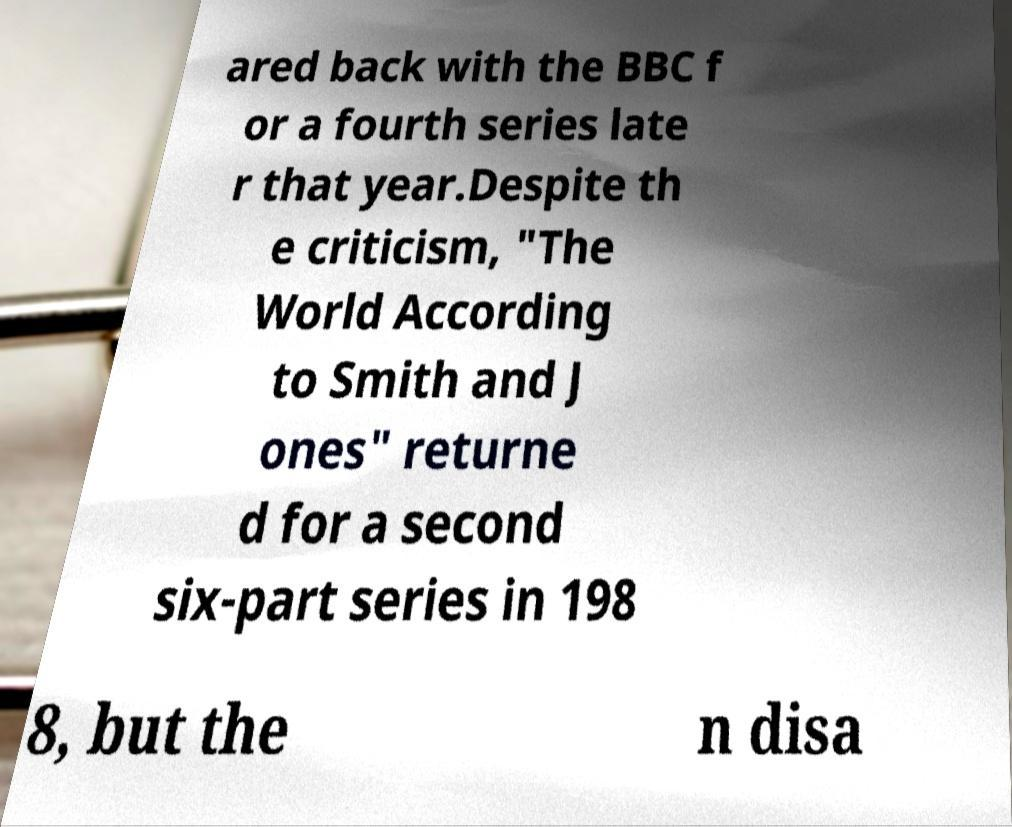There's text embedded in this image that I need extracted. Can you transcribe it verbatim? ared back with the BBC f or a fourth series late r that year.Despite th e criticism, "The World According to Smith and J ones" returne d for a second six-part series in 198 8, but the n disa 